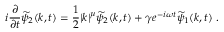Convert formula to latex. <formula><loc_0><loc_0><loc_500><loc_500>i \frac { \partial } { \partial t } \widetilde { \psi } _ { 2 } ( k , t ) = \frac { 1 } { 2 } | k | ^ { \mu } \widetilde { \psi } _ { 2 } ( k , t ) + \gamma e ^ { - i \omega t } \widetilde { \psi } _ { 1 } ( k , t ) \, .</formula> 